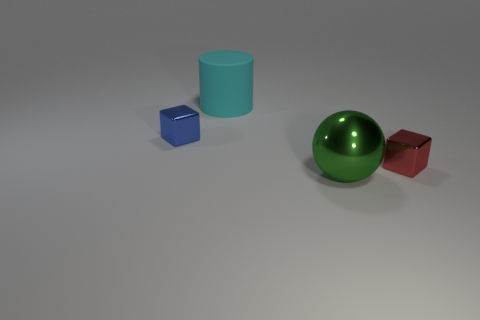Are there any other things that have the same material as the cyan cylinder?
Give a very brief answer. No. How big is the cyan rubber cylinder that is left of the small metallic thing that is on the right side of the metal cube that is on the left side of the metallic ball?
Give a very brief answer. Large. What is the big green thing made of?
Keep it short and to the point. Metal. Is the large ball made of the same material as the object to the right of the green metal sphere?
Keep it short and to the point. Yes. Is there anything else that has the same color as the large matte cylinder?
Provide a short and direct response. No. Are there any objects that are behind the block behind the tiny block to the right of the big rubber cylinder?
Offer a terse response. Yes. The cylinder has what color?
Provide a short and direct response. Cyan. Are there any cyan objects right of the cylinder?
Offer a terse response. No. Is the shape of the small red thing the same as the large green shiny thing that is to the right of the big cylinder?
Give a very brief answer. No. How many other objects are the same material as the large cyan cylinder?
Provide a short and direct response. 0. 